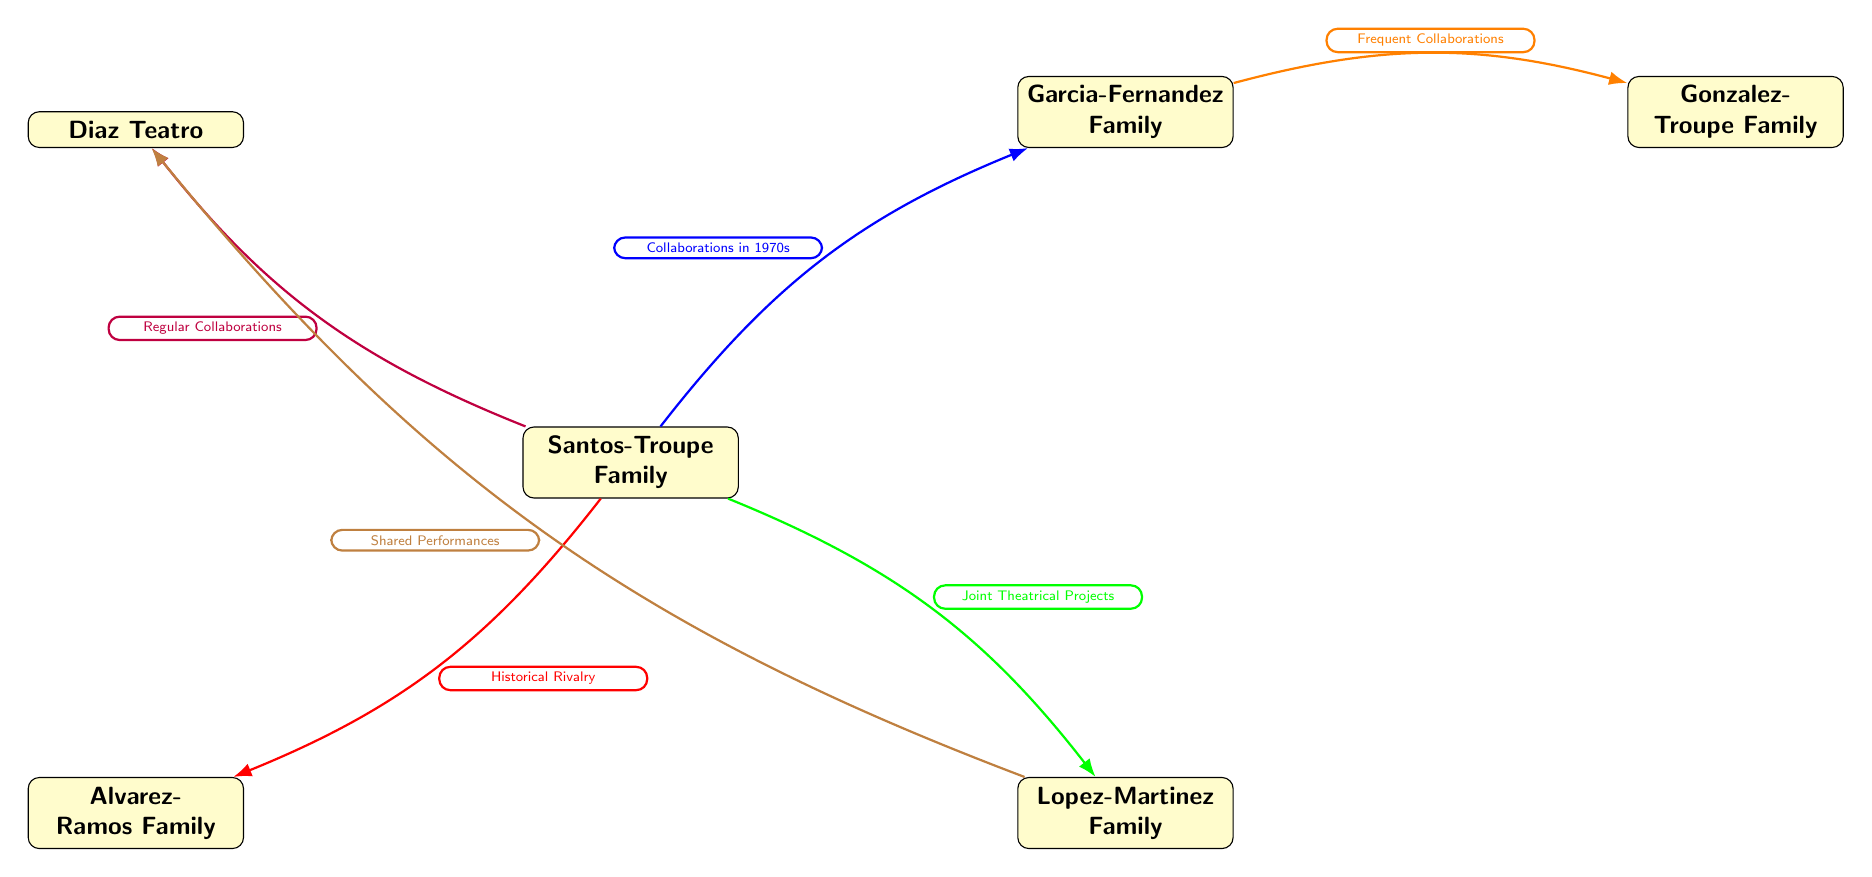What is the primary family in the diagram? The diagram centers around the Santos-Troupe Family node, which is the main connection point to other families depicted.
Answer: Santos-Troupe Family How many families are connected to the Santos-Troupe Family? By counting the edges connecting to the Santos-Troupe Family, we see it links to four other families: Garcia-Fernandez, Lopez-Martinez, Alvarez-Ramos, and Diaz Teatro.
Answer: 4 What type of relationship exists between the Santos-Troupe Family and the Alvarez-Ramos Family? The edge between the Santos-Troupe and Alvarez-Ramos Families is labeled "Historical Rivalry," indicating a competitive relationship.
Answer: Historical Rivalry Which family has a relationship labeled as "Joint Theatrical Projects" with the Santos-Troupe Family? The label on the edge connecting the Santos-Troupe Family and Lopez-Martinez Family specifies "Joint Theatrical Projects," demonstrating their collaboration.
Answer: Lopez-Martinez Family What color represents the relationship labeled "Collaborations in 1970s" between the Santos-Troupe Family and another family? The edge connecting the Santos-Troupe Family to the Garcia-Fernandez Family is represented by a blue color, indicating their collaboration during the 1970s.
Answer: Blue Which family has the relationship "Shared Performances" and is connected to the Diaz Teatro? Looking at the connecting edge, the Lopez-Martinez Family has a relationship labeled "Shared Performances" with Diaz Teatro.
Answer: Lopez-Martinez Family How are the Garcia-Fernandez Family and Gonzalez-Troupe Family connected? The connection is labeled "Frequent Collaborations," indicating a strong working relationship between these two families.
Answer: Frequent Collaborations What is the significance of the color orange in the diagram? The color orange indicates the relationship type "Frequent Collaborations," specifically linking the Garcia-Fernandez Family to Gonzalez-Troupe Family.
Answer: Frequent Collaborations Which family has no direct connection to the Santos-Troupe Family? After reviewing the diagram, the Gonzalez-Troupe Family does not have a direct edge connecting them to the Santos-Troupe Family.
Answer: Gonzalez-Troupe Family 